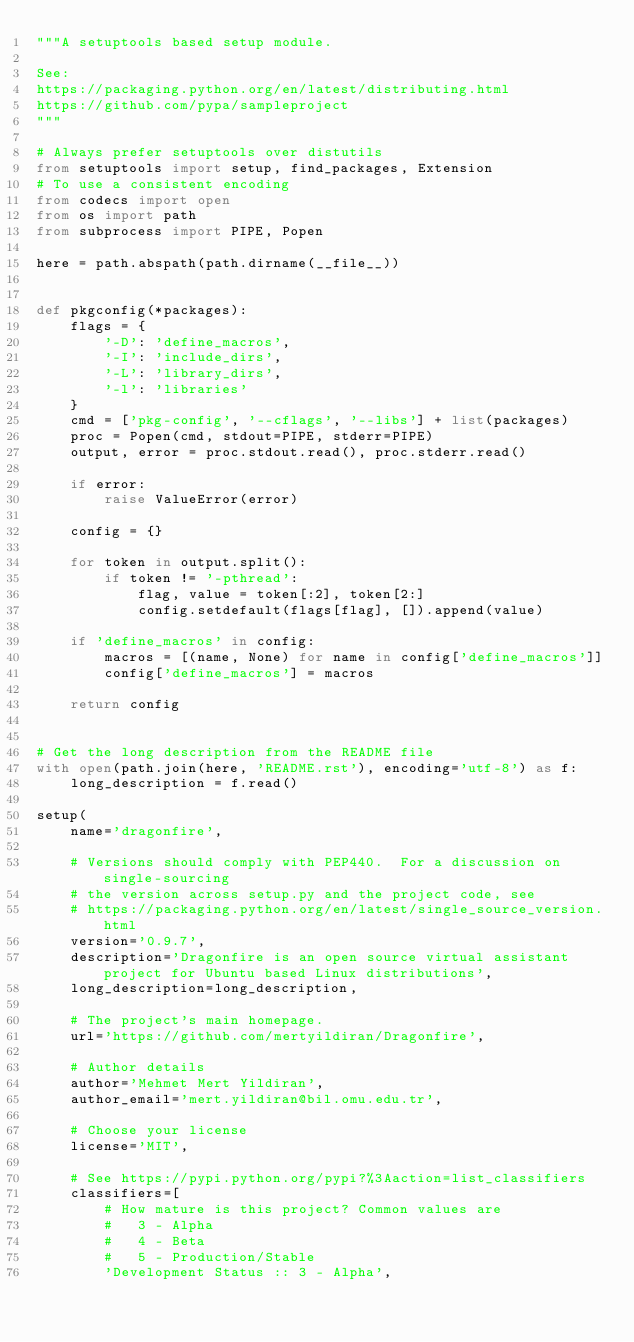Convert code to text. <code><loc_0><loc_0><loc_500><loc_500><_Python_>"""A setuptools based setup module.

See:
https://packaging.python.org/en/latest/distributing.html
https://github.com/pypa/sampleproject
"""

# Always prefer setuptools over distutils
from setuptools import setup, find_packages, Extension
# To use a consistent encoding
from codecs import open
from os import path
from subprocess import PIPE, Popen

here = path.abspath(path.dirname(__file__))


def pkgconfig(*packages):
    flags = {
        '-D': 'define_macros',
        '-I': 'include_dirs',
        '-L': 'library_dirs',
        '-l': 'libraries'
    }
    cmd = ['pkg-config', '--cflags', '--libs'] + list(packages)
    proc = Popen(cmd, stdout=PIPE, stderr=PIPE)
    output, error = proc.stdout.read(), proc.stderr.read()

    if error:
        raise ValueError(error)

    config = {}

    for token in output.split():
        if token != '-pthread':
            flag, value = token[:2], token[2:]
            config.setdefault(flags[flag], []).append(value)

    if 'define_macros' in config:
        macros = [(name, None) for name in config['define_macros']]
        config['define_macros'] = macros

    return config


# Get the long description from the README file
with open(path.join(here, 'README.rst'), encoding='utf-8') as f:
    long_description = f.read()

setup(
    name='dragonfire',

    # Versions should comply with PEP440.  For a discussion on single-sourcing
    # the version across setup.py and the project code, see
    # https://packaging.python.org/en/latest/single_source_version.html
    version='0.9.7',
    description='Dragonfire is an open source virtual assistant project for Ubuntu based Linux distributions',
    long_description=long_description,

    # The project's main homepage.
    url='https://github.com/mertyildiran/Dragonfire',

    # Author details
    author='Mehmet Mert Yildiran',
    author_email='mert.yildiran@bil.omu.edu.tr',

    # Choose your license
    license='MIT',

    # See https://pypi.python.org/pypi?%3Aaction=list_classifiers
    classifiers=[
        # How mature is this project? Common values are
        #   3 - Alpha
        #   4 - Beta
        #   5 - Production/Stable
        'Development Status :: 3 - Alpha',
</code> 